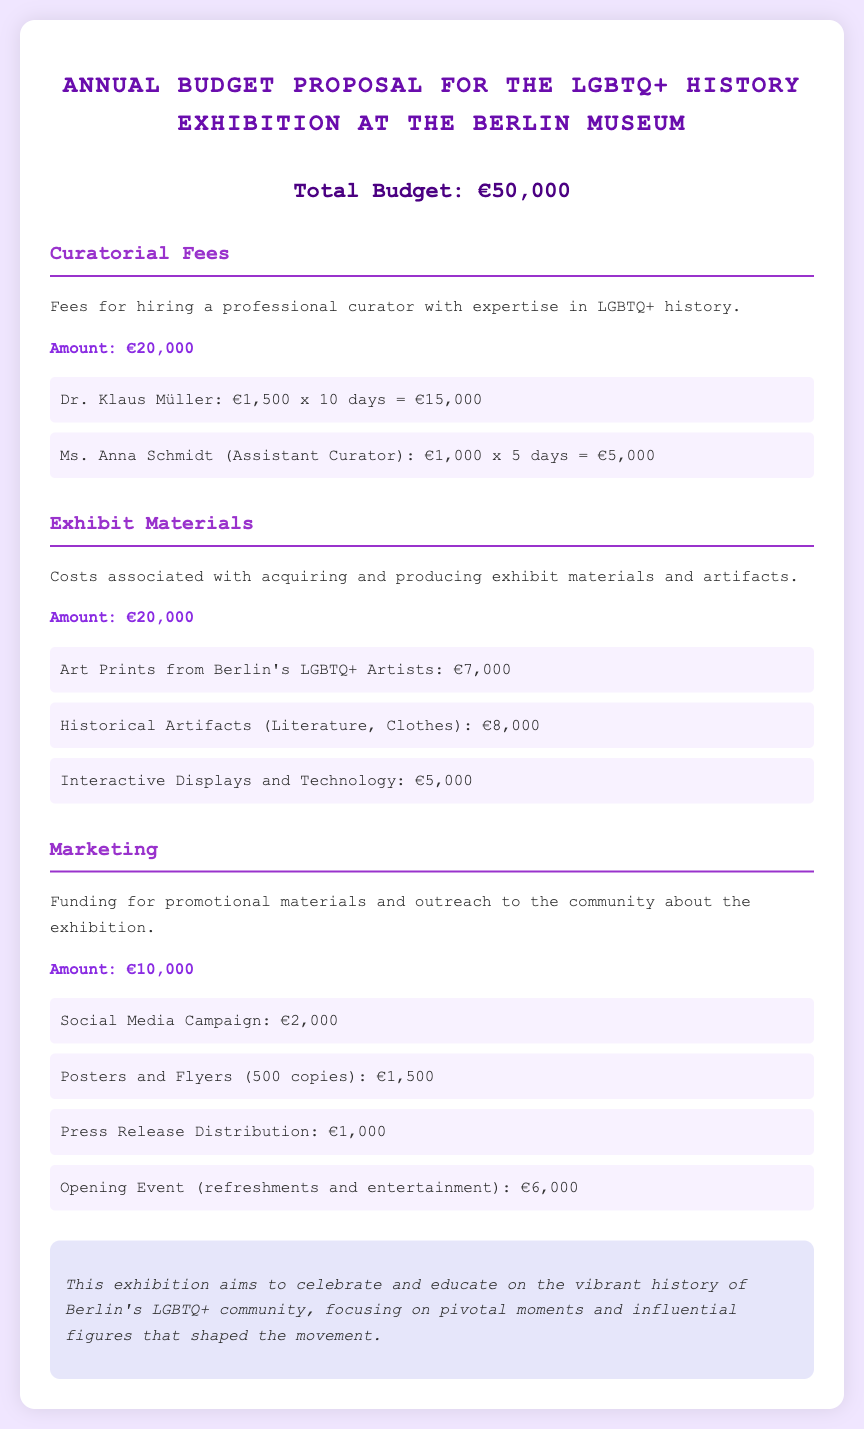What is the total budget for the exhibition? The total budget is stated clearly in the document as €50,000.
Answer: €50,000 What is the amount allocated for curatorial fees? The section on curatorial fees specifies the total amount allocated for this purpose.
Answer: €20,000 Who is the assistant curator listed in the budget? The document mentions Ms. Anna Schmidt as the assistant curator.
Answer: Ms. Anna Schmidt How much will be spent on art prints? The budget details the cost for art prints from Berlin's LGBTQ+ artists.
Answer: €7,000 What is the budget for the opening event? The opening event's budget is provided in the marketing section of the document.
Answer: €6,000 How many days does Dr. Klaus Müller work according to the budget? The document states that Dr. Klaus Müller works for 10 days as part of the curatorial fees.
Answer: 10 days What is the cost for press release distribution? The budget lists the cost specifically for press release distribution under marketing.
Answer: €1,000 What percentage of the total budget is allocated to exhibit materials? Exhibit materials have a specific amount compared to the total budget, allowing for percentage calculation.
Answer: 40% How much is allocated for marketing in total? The marketing budget is clearly outlined, specifying the total amount.
Answer: €10,000 What type of displays are included in the exhibit materials budget? The budget includes a particular type of display mentioned in the exhibit materials section.
Answer: Interactive Displays and Technology 